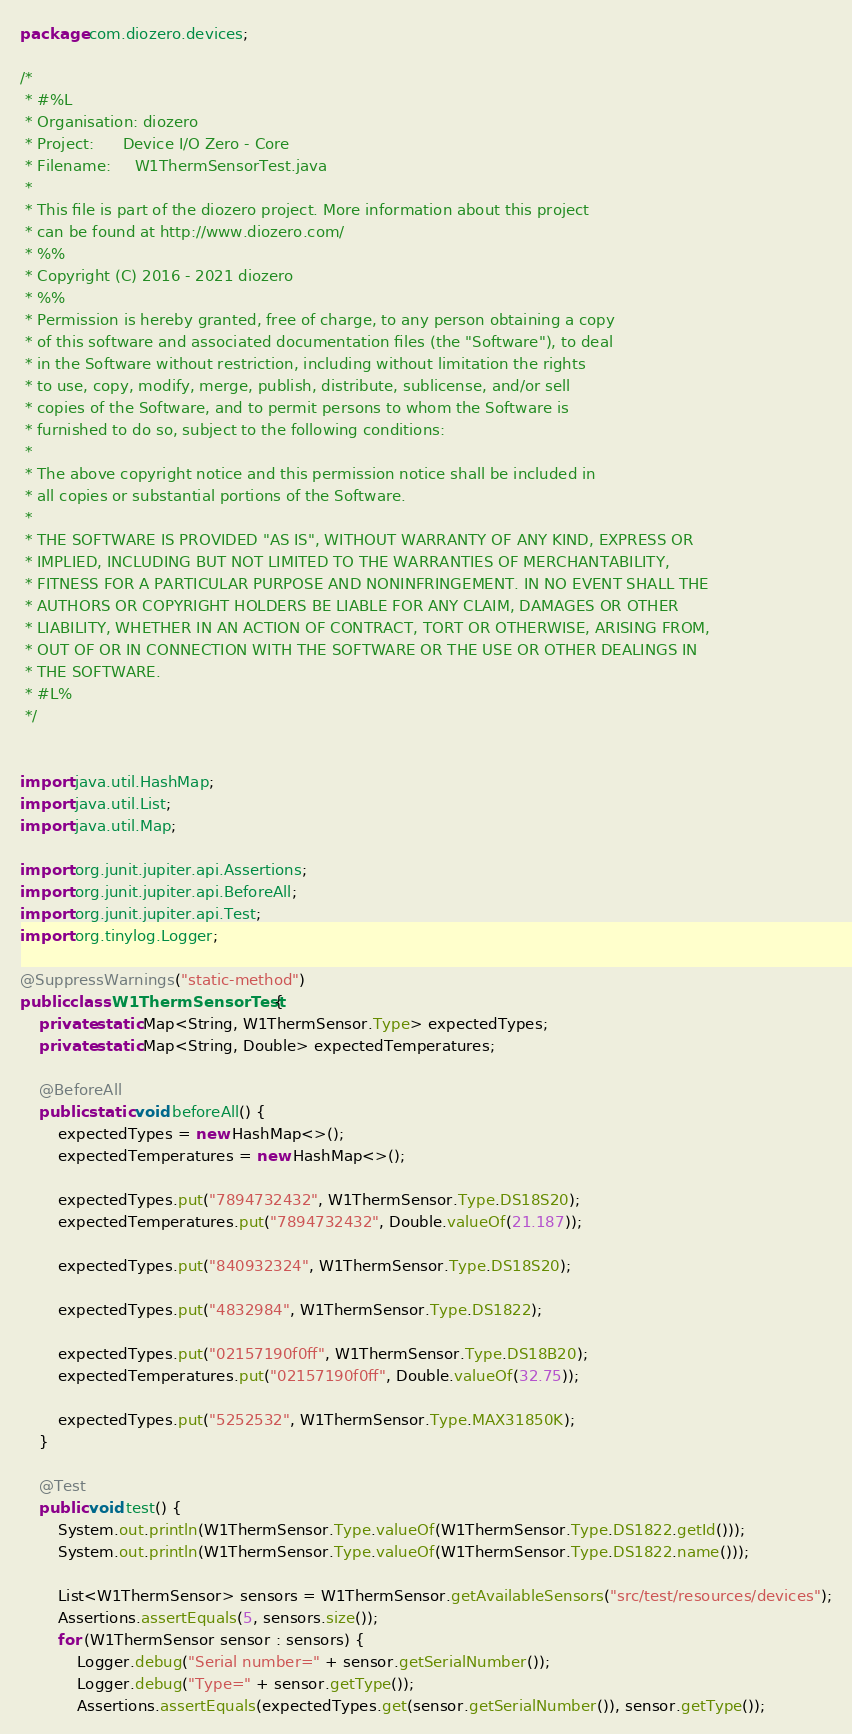<code> <loc_0><loc_0><loc_500><loc_500><_Java_>package com.diozero.devices;

/*
 * #%L
 * Organisation: diozero
 * Project:      Device I/O Zero - Core
 * Filename:     W1ThermSensorTest.java  
 * 
 * This file is part of the diozero project. More information about this project
 * can be found at http://www.diozero.com/
 * %%
 * Copyright (C) 2016 - 2021 diozero
 * %%
 * Permission is hereby granted, free of charge, to any person obtaining a copy
 * of this software and associated documentation files (the "Software"), to deal
 * in the Software without restriction, including without limitation the rights
 * to use, copy, modify, merge, publish, distribute, sublicense, and/or sell
 * copies of the Software, and to permit persons to whom the Software is
 * furnished to do so, subject to the following conditions:
 * 
 * The above copyright notice and this permission notice shall be included in
 * all copies or substantial portions of the Software.
 * 
 * THE SOFTWARE IS PROVIDED "AS IS", WITHOUT WARRANTY OF ANY KIND, EXPRESS OR
 * IMPLIED, INCLUDING BUT NOT LIMITED TO THE WARRANTIES OF MERCHANTABILITY,
 * FITNESS FOR A PARTICULAR PURPOSE AND NONINFRINGEMENT. IN NO EVENT SHALL THE
 * AUTHORS OR COPYRIGHT HOLDERS BE LIABLE FOR ANY CLAIM, DAMAGES OR OTHER
 * LIABILITY, WHETHER IN AN ACTION OF CONTRACT, TORT OR OTHERWISE, ARISING FROM,
 * OUT OF OR IN CONNECTION WITH THE SOFTWARE OR THE USE OR OTHER DEALINGS IN
 * THE SOFTWARE.
 * #L%
 */


import java.util.HashMap;
import java.util.List;
import java.util.Map;

import org.junit.jupiter.api.Assertions;
import org.junit.jupiter.api.BeforeAll;
import org.junit.jupiter.api.Test;
import org.tinylog.Logger;

@SuppressWarnings("static-method")
public class W1ThermSensorTest {
	private static Map<String, W1ThermSensor.Type> expectedTypes;
	private static Map<String, Double> expectedTemperatures;
	
	@BeforeAll
	public static void beforeAll() {
		expectedTypes = new HashMap<>();
		expectedTemperatures = new HashMap<>();
		
		expectedTypes.put("7894732432", W1ThermSensor.Type.DS18S20);
		expectedTemperatures.put("7894732432", Double.valueOf(21.187));
		
		expectedTypes.put("840932324", W1ThermSensor.Type.DS18S20);
		
		expectedTypes.put("4832984", W1ThermSensor.Type.DS1822);
		
		expectedTypes.put("02157190f0ff", W1ThermSensor.Type.DS18B20);
		expectedTemperatures.put("02157190f0ff", Double.valueOf(32.75));
		
		expectedTypes.put("5252532", W1ThermSensor.Type.MAX31850K);
	}
	
	@Test
	public void test() {
		System.out.println(W1ThermSensor.Type.valueOf(W1ThermSensor.Type.DS1822.getId()));
		System.out.println(W1ThermSensor.Type.valueOf(W1ThermSensor.Type.DS1822.name()));
		
		List<W1ThermSensor> sensors = W1ThermSensor.getAvailableSensors("src/test/resources/devices");
		Assertions.assertEquals(5, sensors.size());
		for (W1ThermSensor sensor : sensors) {
			Logger.debug("Serial number=" + sensor.getSerialNumber());
			Logger.debug("Type=" + sensor.getType());
			Assertions.assertEquals(expectedTypes.get(sensor.getSerialNumber()), sensor.getType());</code> 